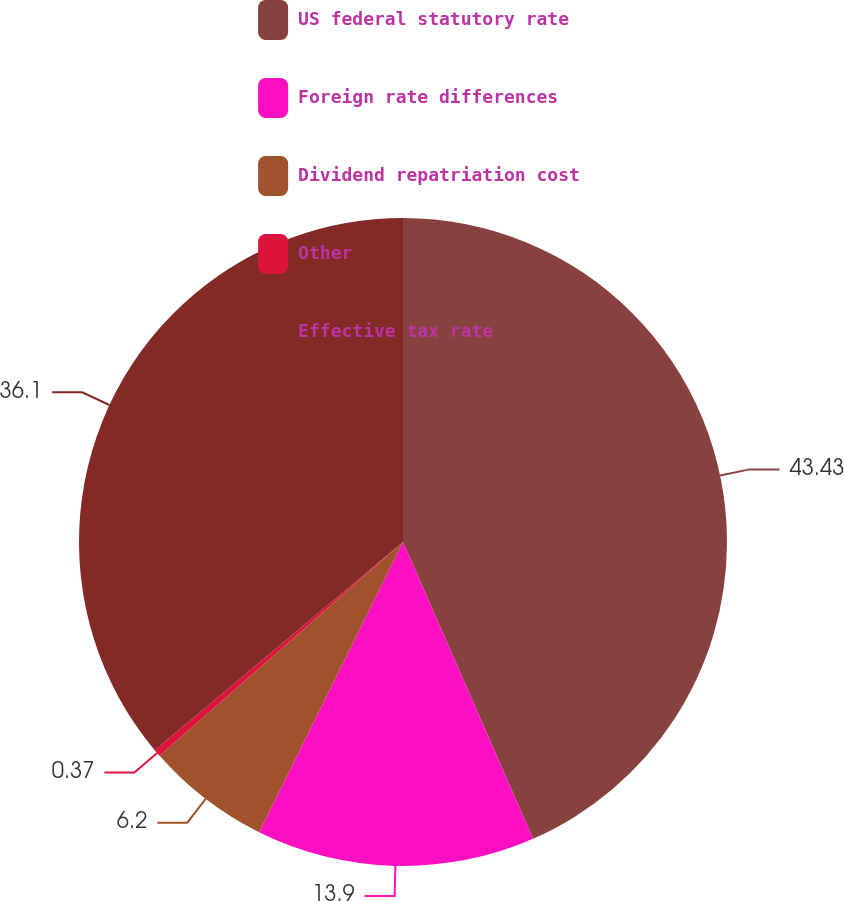<chart> <loc_0><loc_0><loc_500><loc_500><pie_chart><fcel>US federal statutory rate<fcel>Foreign rate differences<fcel>Dividend repatriation cost<fcel>Other<fcel>Effective tax rate<nl><fcel>43.42%<fcel>13.9%<fcel>6.2%<fcel>0.37%<fcel>36.1%<nl></chart> 